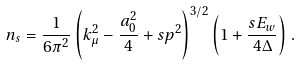Convert formula to latex. <formula><loc_0><loc_0><loc_500><loc_500>n _ { s } = \frac { 1 } { 6 \pi ^ { 2 } } \left ( k _ { \mu } ^ { 2 } - \frac { a _ { 0 } ^ { 2 } } { 4 } + s p ^ { 2 } \right ) ^ { 3 / 2 } \left ( 1 + \frac { s E _ { w } } { 4 \Delta } \right ) \, .</formula> 